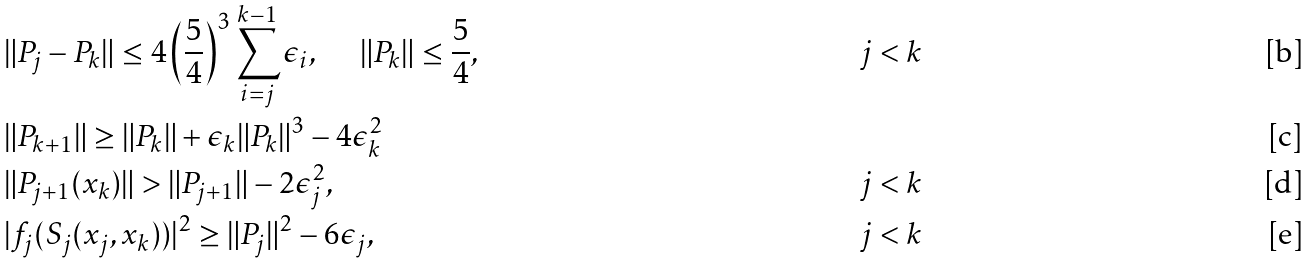Convert formula to latex. <formula><loc_0><loc_0><loc_500><loc_500>& \| P _ { j } - P _ { k } \| \leq 4 \left ( \frac { 5 } { 4 } \right ) ^ { 3 } \sum _ { i = j } ^ { k - 1 } \epsilon _ { i } , \quad \ \| P _ { k } \| \leq \frac { 5 } { 4 } , & j < k \\ & \| P _ { k + 1 } \| \geq \| P _ { k } \| + \epsilon _ { k } \| P _ { k } \| ^ { 3 } - 4 \epsilon _ { k } ^ { 2 } & \\ & \| P _ { j + 1 } ( x _ { k } ) \| > \| P _ { j + 1 } \| - 2 \epsilon _ { j } ^ { 2 } , & j < k \\ & | f _ { j } ( S _ { j } ( x _ { j } , x _ { k } ) ) | ^ { 2 } \geq \| P _ { j } \| ^ { 2 } - 6 \epsilon _ { j } , & j < k</formula> 